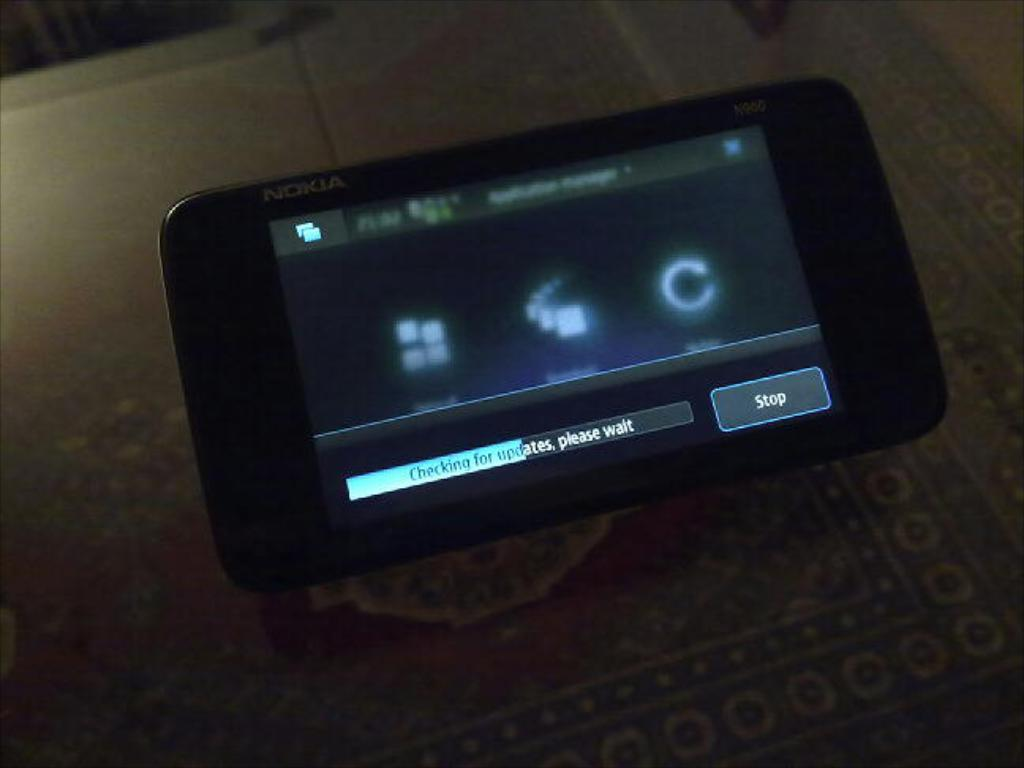<image>
Give a short and clear explanation of the subsequent image. a phone that says it is checking for updates 